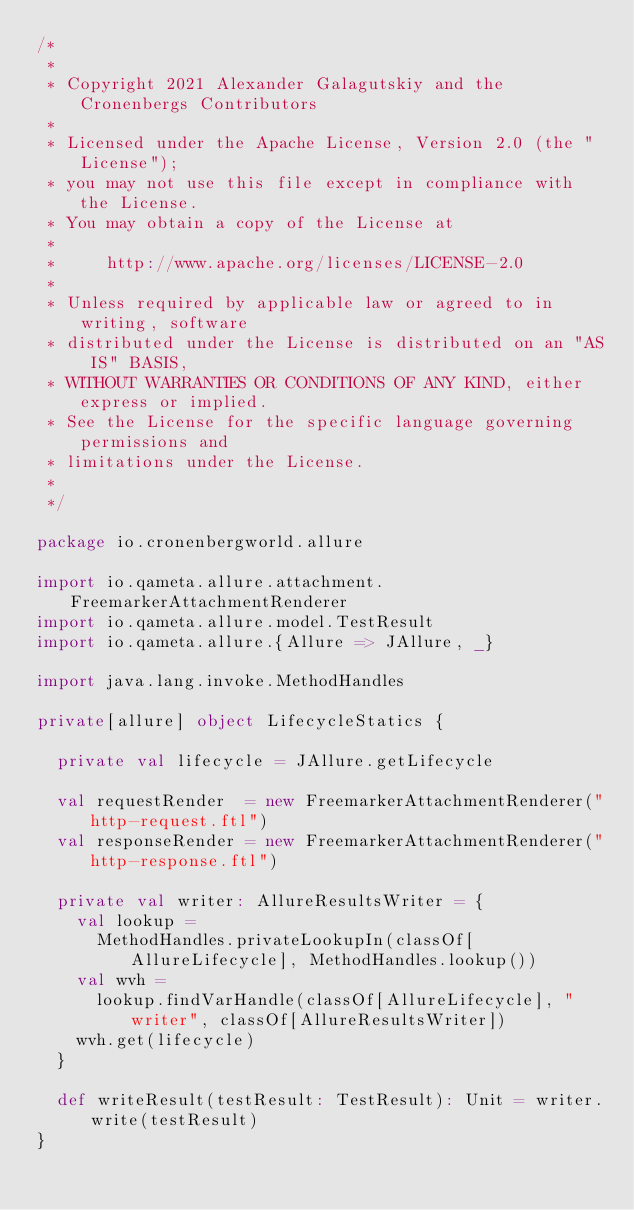Convert code to text. <code><loc_0><loc_0><loc_500><loc_500><_Scala_>/*
 *
 * Copyright 2021 Alexander Galagutskiy and the Cronenbergs Contributors
 *
 * Licensed under the Apache License, Version 2.0 (the "License");
 * you may not use this file except in compliance with the License.
 * You may obtain a copy of the License at
 *
 *     http://www.apache.org/licenses/LICENSE-2.0
 *
 * Unless required by applicable law or agreed to in writing, software
 * distributed under the License is distributed on an "AS IS" BASIS,
 * WITHOUT WARRANTIES OR CONDITIONS OF ANY KIND, either express or implied.
 * See the License for the specific language governing permissions and
 * limitations under the License.
 *
 */

package io.cronenbergworld.allure

import io.qameta.allure.attachment.FreemarkerAttachmentRenderer
import io.qameta.allure.model.TestResult
import io.qameta.allure.{Allure => JAllure, _}

import java.lang.invoke.MethodHandles

private[allure] object LifecycleStatics {

  private val lifecycle = JAllure.getLifecycle

  val requestRender  = new FreemarkerAttachmentRenderer("http-request.ftl")
  val responseRender = new FreemarkerAttachmentRenderer("http-response.ftl")

  private val writer: AllureResultsWriter = {
    val lookup =
      MethodHandles.privateLookupIn(classOf[AllureLifecycle], MethodHandles.lookup())
    val wvh =
      lookup.findVarHandle(classOf[AllureLifecycle], "writer", classOf[AllureResultsWriter])
    wvh.get(lifecycle)
  }

  def writeResult(testResult: TestResult): Unit = writer.write(testResult)
}
</code> 